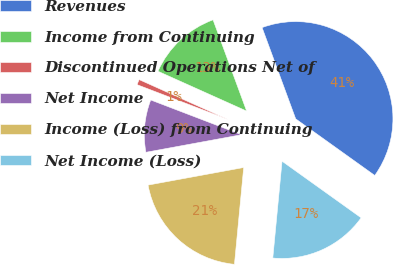Convert chart. <chart><loc_0><loc_0><loc_500><loc_500><pie_chart><fcel>Revenues<fcel>Income from Continuing<fcel>Discontinued Operations Net of<fcel>Net Income<fcel>Income (Loss) from Continuing<fcel>Net Income (Loss)<nl><fcel>40.5%<fcel>12.67%<fcel>0.9%<fcel>8.71%<fcel>20.59%<fcel>16.63%<nl></chart> 